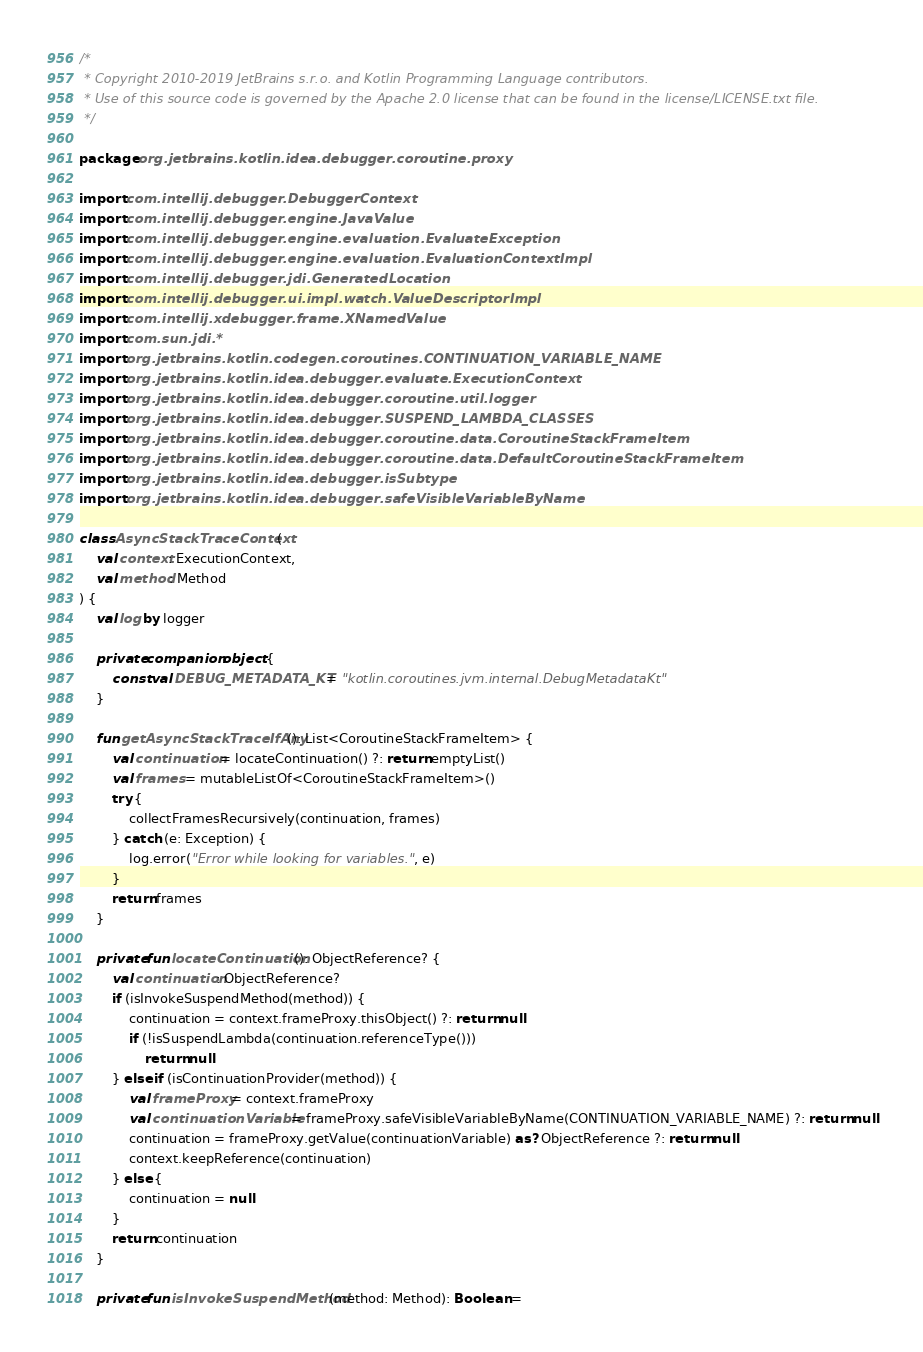<code> <loc_0><loc_0><loc_500><loc_500><_Kotlin_>/*
 * Copyright 2010-2019 JetBrains s.r.o. and Kotlin Programming Language contributors.
 * Use of this source code is governed by the Apache 2.0 license that can be found in the license/LICENSE.txt file.
 */

package org.jetbrains.kotlin.idea.debugger.coroutine.proxy

import com.intellij.debugger.DebuggerContext
import com.intellij.debugger.engine.JavaValue
import com.intellij.debugger.engine.evaluation.EvaluateException
import com.intellij.debugger.engine.evaluation.EvaluationContextImpl
import com.intellij.debugger.jdi.GeneratedLocation
import com.intellij.debugger.ui.impl.watch.ValueDescriptorImpl
import com.intellij.xdebugger.frame.XNamedValue
import com.sun.jdi.*
import org.jetbrains.kotlin.codegen.coroutines.CONTINUATION_VARIABLE_NAME
import org.jetbrains.kotlin.idea.debugger.evaluate.ExecutionContext
import org.jetbrains.kotlin.idea.debugger.coroutine.util.logger
import org.jetbrains.kotlin.idea.debugger.SUSPEND_LAMBDA_CLASSES
import org.jetbrains.kotlin.idea.debugger.coroutine.data.CoroutineStackFrameItem
import org.jetbrains.kotlin.idea.debugger.coroutine.data.DefaultCoroutineStackFrameItem
import org.jetbrains.kotlin.idea.debugger.isSubtype
import org.jetbrains.kotlin.idea.debugger.safeVisibleVariableByName

class AsyncStackTraceContext(
    val context: ExecutionContext,
    val method: Method
) {
    val log by logger

    private companion object {
        const val DEBUG_METADATA_KT = "kotlin.coroutines.jvm.internal.DebugMetadataKt"
    }

    fun getAsyncStackTraceIfAny(): List<CoroutineStackFrameItem> {
        val continuation = locateContinuation() ?: return emptyList()
        val frames = mutableListOf<CoroutineStackFrameItem>()
        try {
            collectFramesRecursively(continuation, frames)
        } catch (e: Exception) {
            log.error("Error while looking for variables.", e)
        }
        return frames
    }

    private fun locateContinuation(): ObjectReference? {
        val continuation: ObjectReference?
        if (isInvokeSuspendMethod(method)) {
            continuation = context.frameProxy.thisObject() ?: return null
            if (!isSuspendLambda(continuation.referenceType()))
                return null
        } else if (isContinuationProvider(method)) {
            val frameProxy = context.frameProxy
            val continuationVariable = frameProxy.safeVisibleVariableByName(CONTINUATION_VARIABLE_NAME) ?: return null
            continuation = frameProxy.getValue(continuationVariable) as? ObjectReference ?: return null
            context.keepReference(continuation)
        } else {
            continuation = null
        }
        return continuation
    }

    private fun isInvokeSuspendMethod(method: Method): Boolean =</code> 